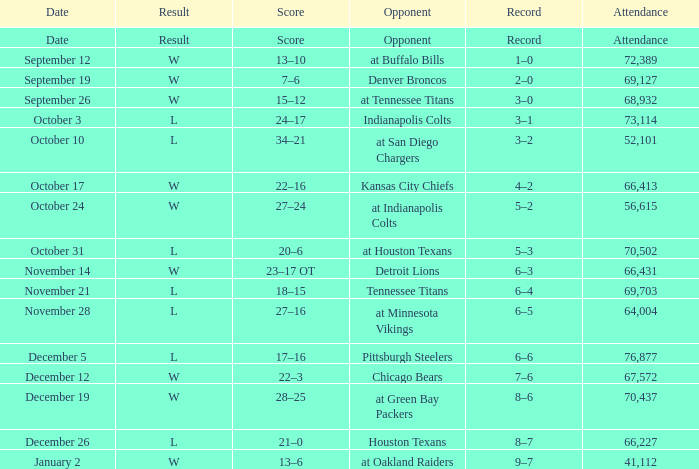What attendance figures are there for detroit lions as the opponent? 66431.0. 